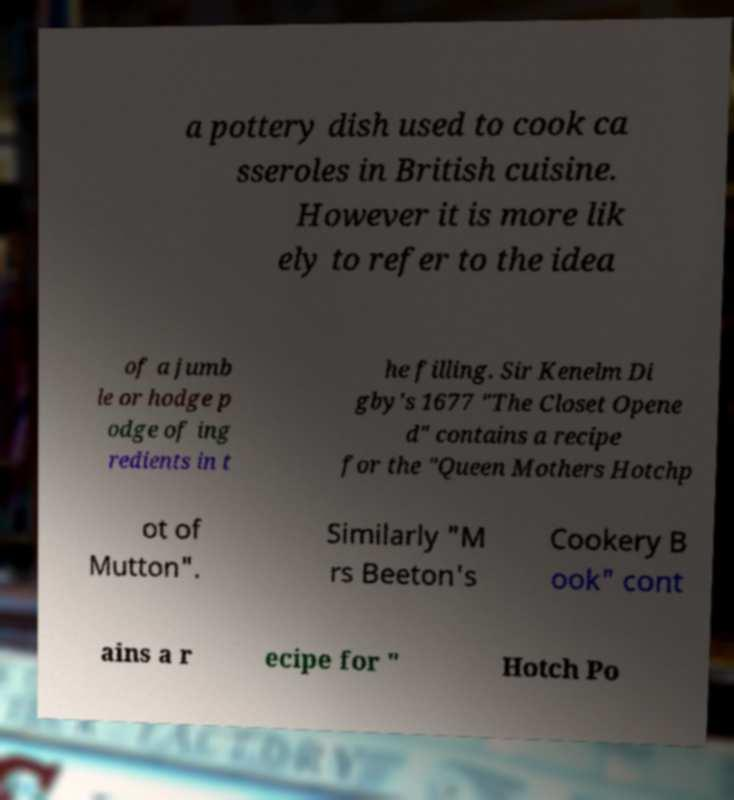There's text embedded in this image that I need extracted. Can you transcribe it verbatim? a pottery dish used to cook ca sseroles in British cuisine. However it is more lik ely to refer to the idea of a jumb le or hodge p odge of ing redients in t he filling. Sir Kenelm Di gby's 1677 "The Closet Opene d" contains a recipe for the "Queen Mothers Hotchp ot of Mutton". Similarly "M rs Beeton's Cookery B ook" cont ains a r ecipe for " Hotch Po 